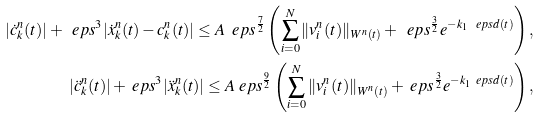<formula> <loc_0><loc_0><loc_500><loc_500>| \dot { c } _ { k } ^ { n } ( t ) | + \ e p s ^ { 3 } | \dot { x } _ { k } ^ { n } ( t ) - c _ { k } ^ { n } ( t ) | \leq A \ e p s ^ { \frac { 7 } { 2 } } \left ( \sum _ { i = 0 } ^ { N } \| v _ { i } ^ { n } ( t ) \| _ { W ^ { n } ( t ) } + \ e p s ^ { \frac { 3 } { 2 } } e ^ { - k _ { 1 } \ e p s d ( t ) } \right ) , \\ | \ddot { c } _ { k } ^ { n } ( t ) | + \ e p s ^ { 3 } | \ddot { x } _ { k } ^ { n } ( t ) | \leq A \ e p s ^ { \frac { 9 } { 2 } } \left ( \sum _ { i = 0 } ^ { N } \| v _ { i } ^ { n } ( t ) \| _ { W ^ { n } ( t ) } + \ e p s ^ { \frac { 3 } { 2 } } e ^ { - k _ { 1 } \ e p s d ( t ) } \right ) ,</formula> 